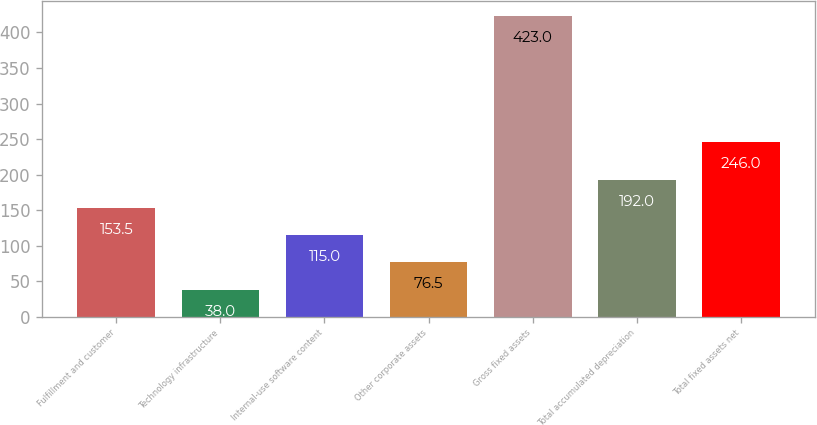Convert chart. <chart><loc_0><loc_0><loc_500><loc_500><bar_chart><fcel>Fulfillment and customer<fcel>Technology infrastructure<fcel>Internal-use software content<fcel>Other corporate assets<fcel>Gross fixed assets<fcel>Total accumulated depreciation<fcel>Total fixed assets net<nl><fcel>153.5<fcel>38<fcel>115<fcel>76.5<fcel>423<fcel>192<fcel>246<nl></chart> 